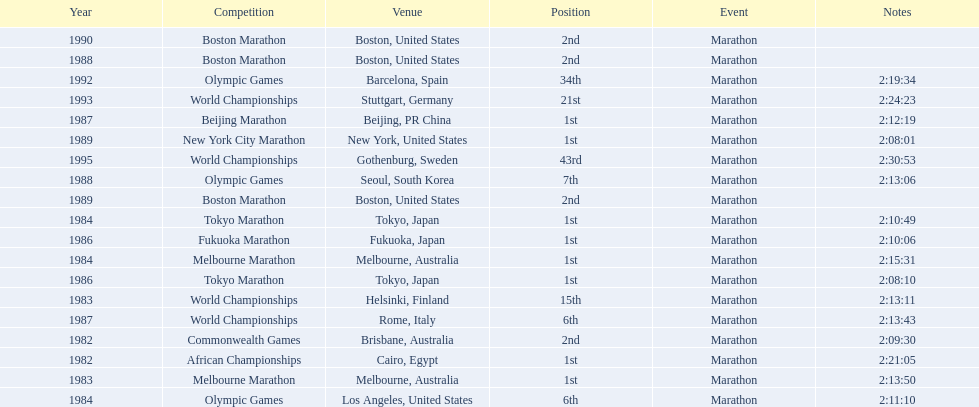What are all the competitions? African Championships, Commonwealth Games, World Championships, Melbourne Marathon, Tokyo Marathon, Olympic Games, Melbourne Marathon, Tokyo Marathon, Fukuoka Marathon, World Championships, Beijing Marathon, Olympic Games, Boston Marathon, New York City Marathon, Boston Marathon, Boston Marathon, Olympic Games, World Championships, World Championships. Where were they located? Cairo, Egypt, Brisbane, Australia, Helsinki, Finland, Melbourne, Australia, Tokyo, Japan, Los Angeles, United States, Melbourne, Australia, Tokyo, Japan, Fukuoka, Japan, Rome, Italy, Beijing, PR China, Seoul, South Korea, Boston, United States, New York, United States, Boston, United States, Boston, United States, Barcelona, Spain, Stuttgart, Germany, Gothenburg, Sweden. And which competition was in china? Beijing Marathon. 